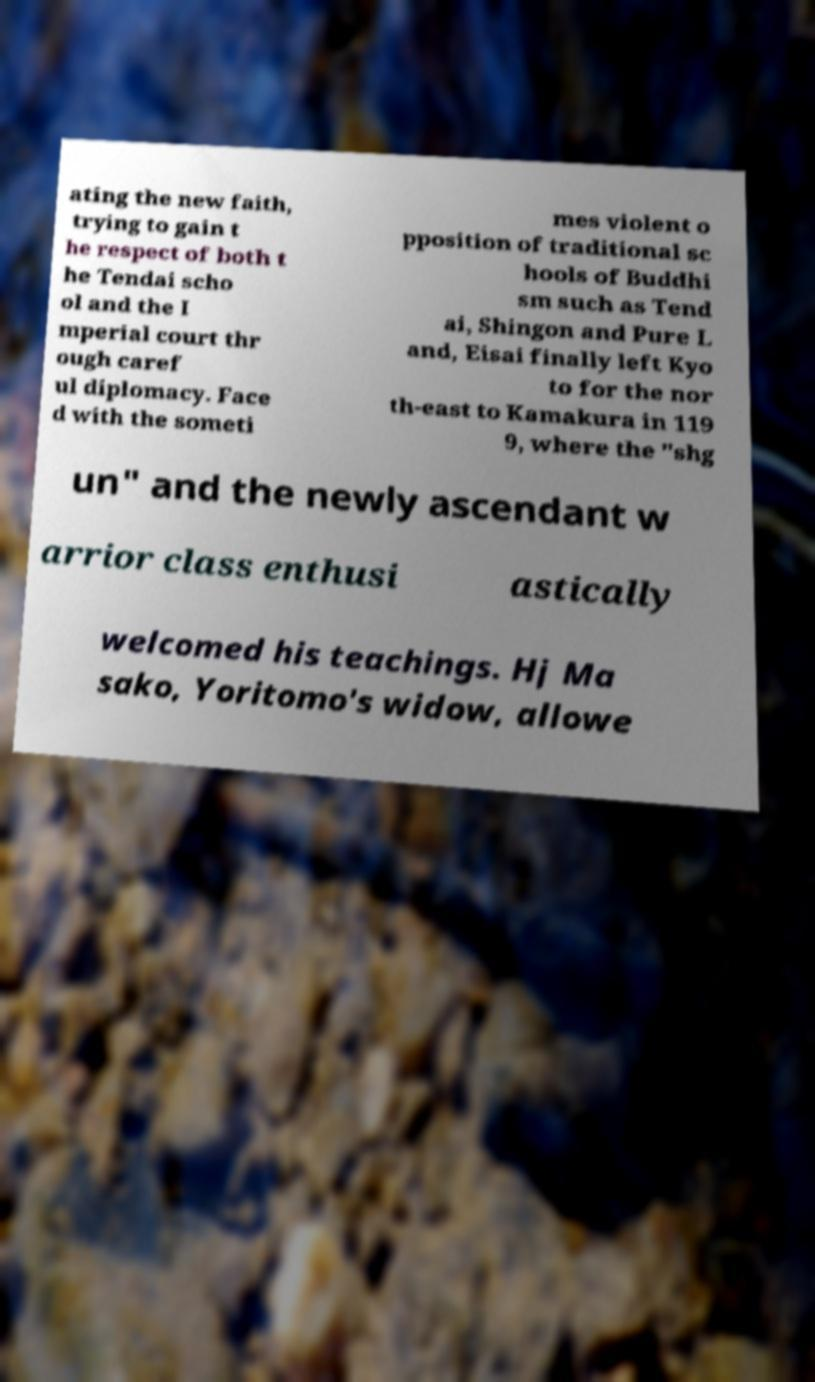Please identify and transcribe the text found in this image. ating the new faith, trying to gain t he respect of both t he Tendai scho ol and the I mperial court thr ough caref ul diplomacy. Face d with the someti mes violent o pposition of traditional sc hools of Buddhi sm such as Tend ai, Shingon and Pure L and, Eisai finally left Kyo to for the nor th-east to Kamakura in 119 9, where the "shg un" and the newly ascendant w arrior class enthusi astically welcomed his teachings. Hj Ma sako, Yoritomo's widow, allowe 